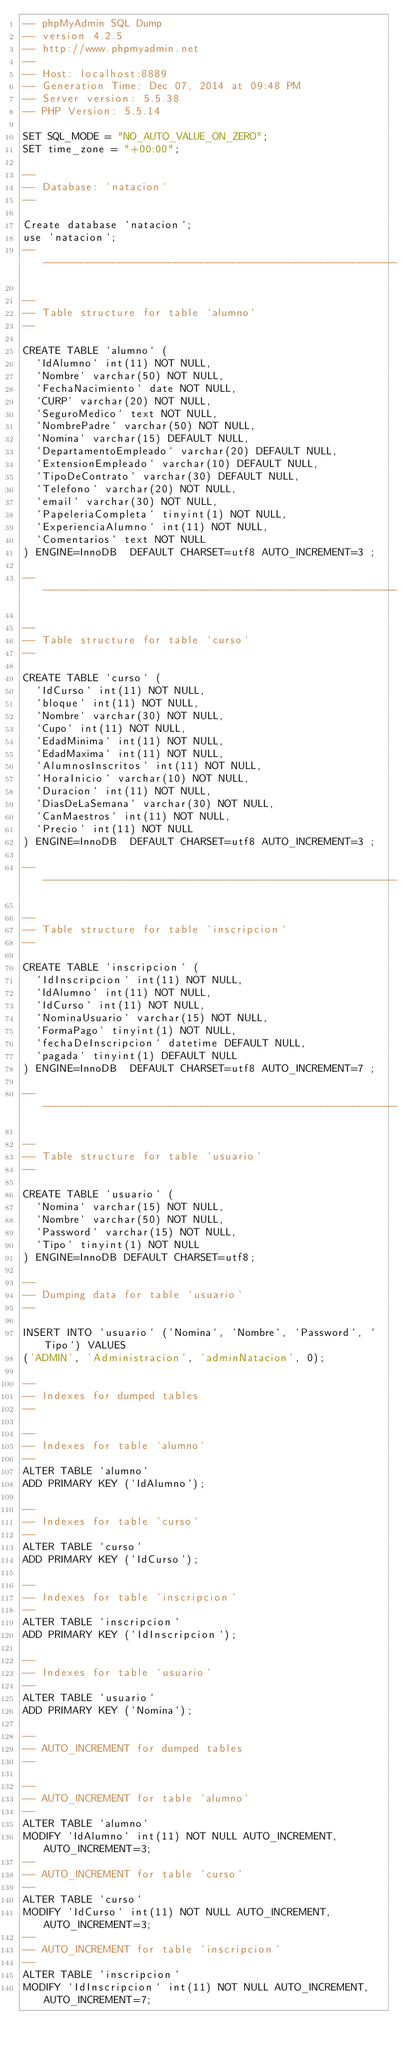<code> <loc_0><loc_0><loc_500><loc_500><_SQL_>-- phpMyAdmin SQL Dump
-- version 4.2.5
-- http://www.phpmyadmin.net
--
-- Host: localhost:8889
-- Generation Time: Dec 07, 2014 at 09:48 PM
-- Server version: 5.5.38
-- PHP Version: 5.5.14

SET SQL_MODE = "NO_AUTO_VALUE_ON_ZERO";
SET time_zone = "+00:00";

--
-- Database: `natacion`
--

Create database `natacion`;
use `natacion`;
-- --------------------------------------------------------

--
-- Table structure for table `alumno`
--

CREATE TABLE `alumno` (
  `IdAlumno` int(11) NOT NULL,
  `Nombre` varchar(50) NOT NULL,
  `FechaNacimiento` date NOT NULL,
  `CURP` varchar(20) NOT NULL,
  `SeguroMedico` text NOT NULL,
  `NombrePadre` varchar(50) NOT NULL,
  `Nomina` varchar(15) DEFAULT NULL,
  `DepartamentoEmpleado` varchar(20) DEFAULT NULL,
  `ExtensionEmpleado` varchar(10) DEFAULT NULL,
  `TipoDeContrato` varchar(30) DEFAULT NULL,
  `Telefono` varchar(20) NOT NULL,
  `email` varchar(30) NOT NULL,
  `PapeleriaCompleta` tinyint(1) NOT NULL,
  `ExperienciaAlumno` int(11) NOT NULL,
  `Comentarios` text NOT NULL
) ENGINE=InnoDB  DEFAULT CHARSET=utf8 AUTO_INCREMENT=3 ;

-- --------------------------------------------------------

--
-- Table structure for table `curso`
--

CREATE TABLE `curso` (
  `IdCurso` int(11) NOT NULL,
  `bloque` int(11) NOT NULL,
  `Nombre` varchar(30) NOT NULL,
  `Cupo` int(11) NOT NULL,
  `EdadMinima` int(11) NOT NULL,
  `EdadMaxima` int(11) NOT NULL,
  `AlumnosInscritos` int(11) NOT NULL,
  `HoraInicio` varchar(10) NOT NULL,
  `Duracion` int(11) NOT NULL,
  `DiasDeLaSemana` varchar(30) NOT NULL,
  `CanMaestros` int(11) NOT NULL,
  `Precio` int(11) NOT NULL
) ENGINE=InnoDB  DEFAULT CHARSET=utf8 AUTO_INCREMENT=3 ;

-- --------------------------------------------------------

--
-- Table structure for table `inscripcion`
--

CREATE TABLE `inscripcion` (
  `IdInscripcion` int(11) NOT NULL,
  `IdAlumno` int(11) NOT NULL,
  `IdCurso` int(11) NOT NULL,
  `NominaUsuario` varchar(15) NOT NULL,
  `FormaPago` tinyint(1) NOT NULL,
  `fechaDeInscripcion` datetime DEFAULT NULL,
  `pagada` tinyint(1) DEFAULT NULL
) ENGINE=InnoDB  DEFAULT CHARSET=utf8 AUTO_INCREMENT=7 ;

-- --------------------------------------------------------

--
-- Table structure for table `usuario`
--

CREATE TABLE `usuario` (
  `Nomina` varchar(15) NOT NULL,
  `Nombre` varchar(50) NOT NULL,
  `Password` varchar(15) NOT NULL,
  `Tipo` tinyint(1) NOT NULL
) ENGINE=InnoDB DEFAULT CHARSET=utf8;

--
-- Dumping data for table `usuario`
--

INSERT INTO `usuario` (`Nomina`, `Nombre`, `Password`, `Tipo`) VALUES
('ADMIN', 'Administracion', 'adminNatacion', 0);

--
-- Indexes for dumped tables
--

--
-- Indexes for table `alumno`
--
ALTER TABLE `alumno`
ADD PRIMARY KEY (`IdAlumno`);

--
-- Indexes for table `curso`
--
ALTER TABLE `curso`
ADD PRIMARY KEY (`IdCurso`);

--
-- Indexes for table `inscripcion`
--
ALTER TABLE `inscripcion`
ADD PRIMARY KEY (`IdInscripcion`);

--
-- Indexes for table `usuario`
--
ALTER TABLE `usuario`
ADD PRIMARY KEY (`Nomina`);

--
-- AUTO_INCREMENT for dumped tables
--

--
-- AUTO_INCREMENT for table `alumno`
--
ALTER TABLE `alumno`
MODIFY `IdAlumno` int(11) NOT NULL AUTO_INCREMENT,AUTO_INCREMENT=3;
--
-- AUTO_INCREMENT for table `curso`
--
ALTER TABLE `curso`
MODIFY `IdCurso` int(11) NOT NULL AUTO_INCREMENT,AUTO_INCREMENT=3;
--
-- AUTO_INCREMENT for table `inscripcion`
--
ALTER TABLE `inscripcion`
MODIFY `IdInscripcion` int(11) NOT NULL AUTO_INCREMENT,AUTO_INCREMENT=7;
</code> 